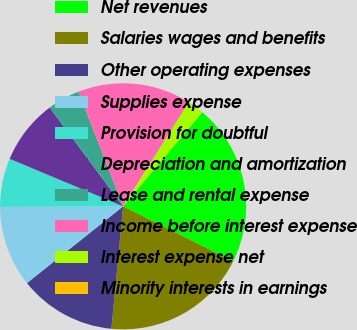<chart> <loc_0><loc_0><loc_500><loc_500><pie_chart><fcel>Net revenues<fcel>Salaries wages and benefits<fcel>Other operating expenses<fcel>Supplies expense<fcel>Provision for doubtful<fcel>Depreciation and amortization<fcel>Lease and rental expense<fcel>Income before interest expense<fcel>Interest expense net<fcel>Minority interests in earnings<nl><fcel>21.25%<fcel>19.13%<fcel>12.76%<fcel>10.64%<fcel>6.39%<fcel>8.51%<fcel>4.27%<fcel>14.88%<fcel>2.14%<fcel>0.02%<nl></chart> 